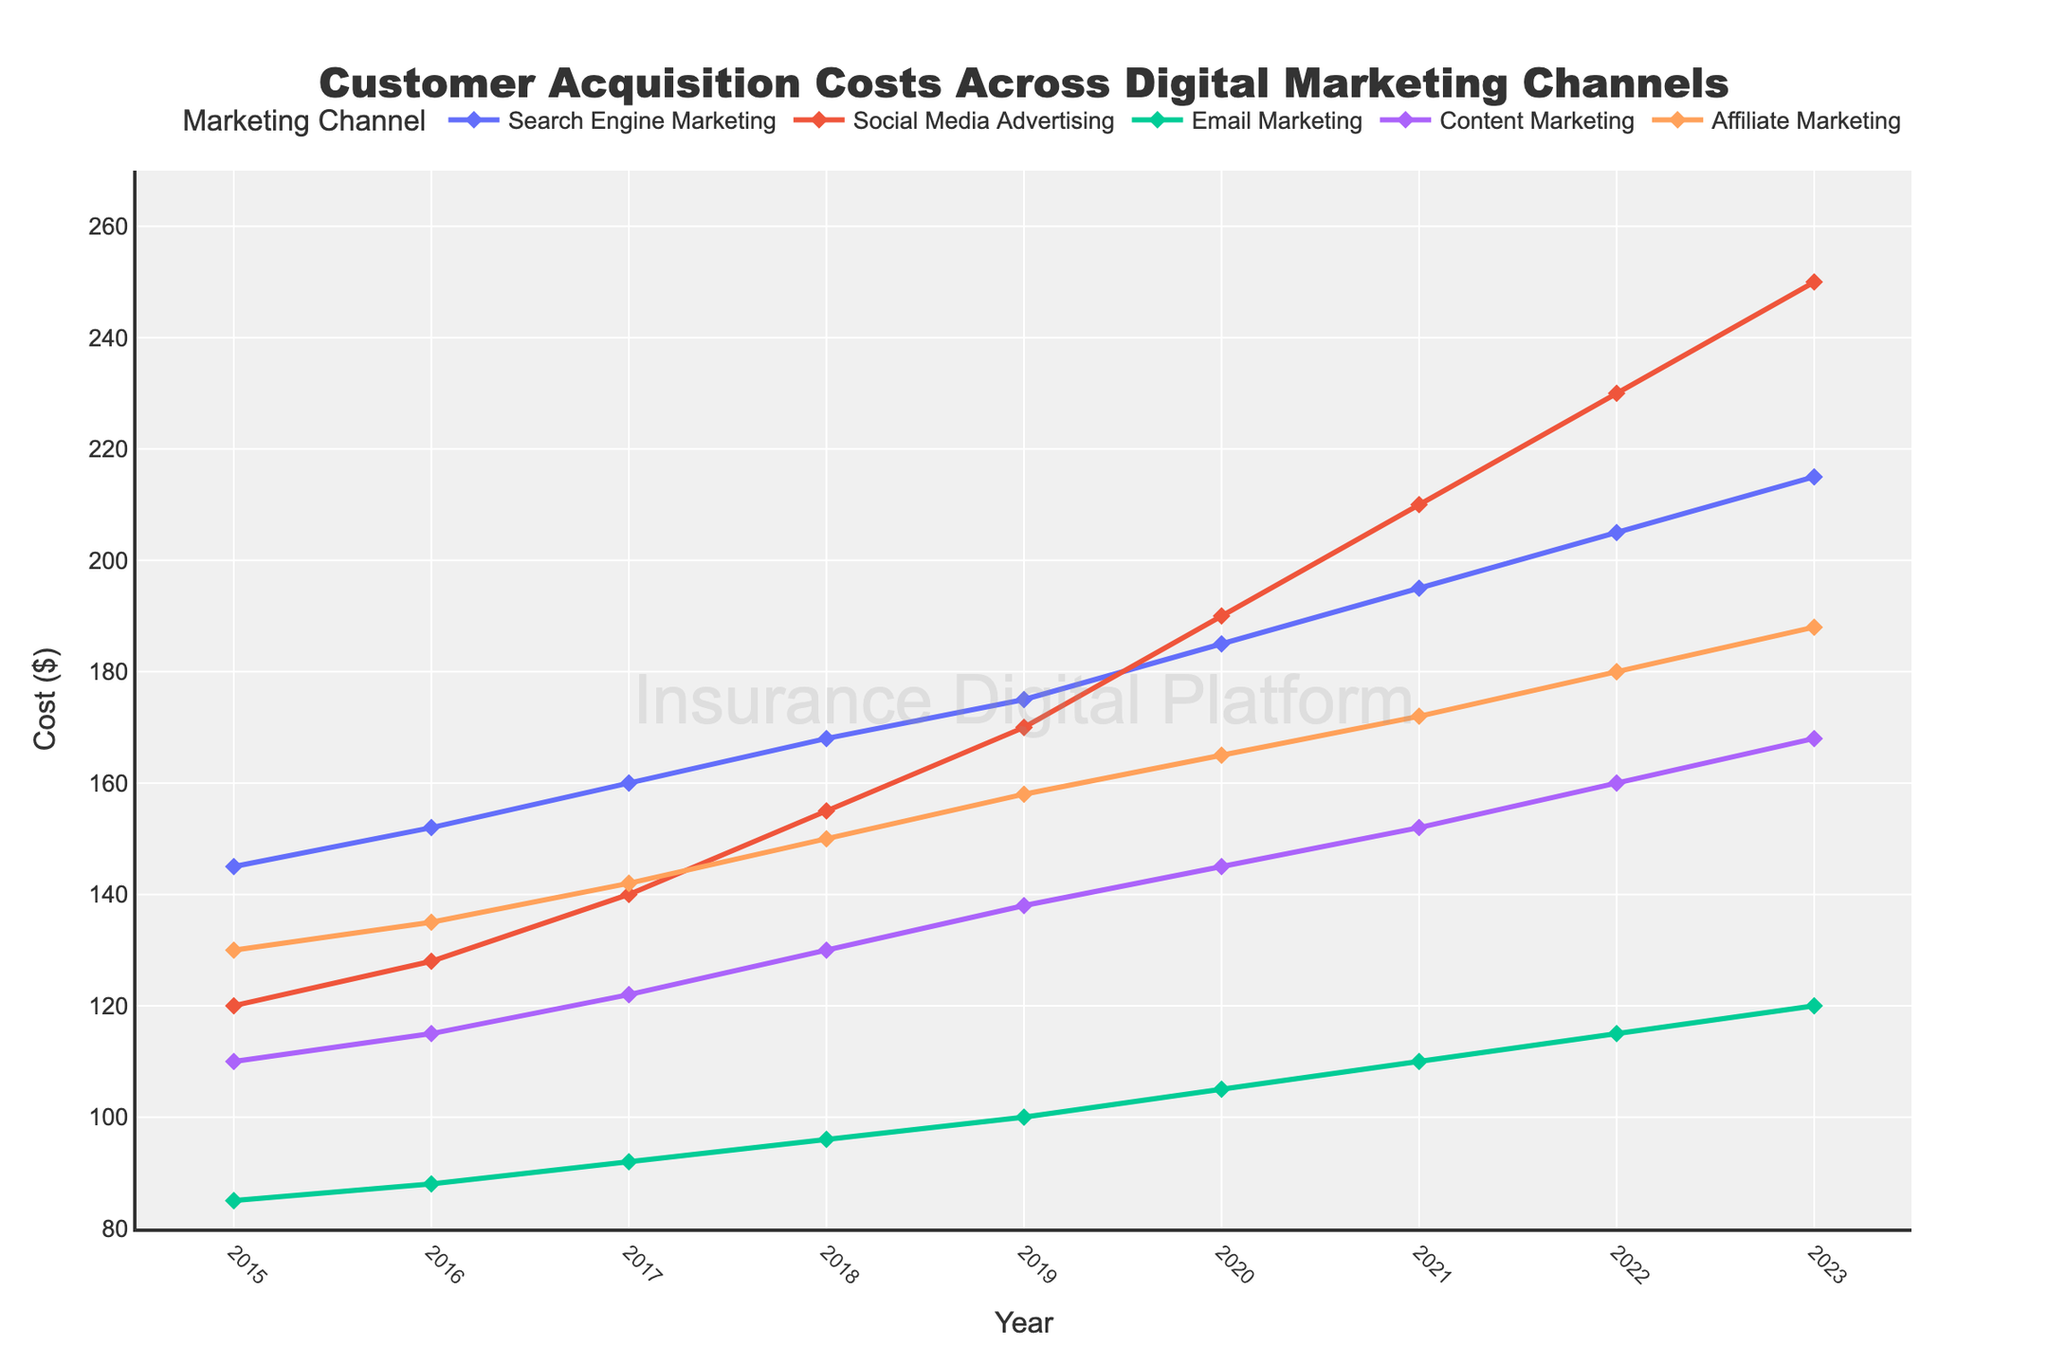what is the increase in cost for Search Engine Marketing from 2015 to 2023? First, locate the values for Search Engine Marketing in 2015 and 2023. They are $145 and $215 respectively. The increase is calculated as 215 - 145.
Answer: 70 Which digital marketing channel had the highest customer acquisition cost in 2023? Identify the cost values for all the digital marketing channels in 2023. The values are Search Engine Marketing ($215), Social Media Advertising ($250), Email Marketing ($120), Content Marketing ($168), and Affiliate Marketing ($188). Social Media Advertising has the highest value.
Answer: Social Media Advertising Between which consecutive years did Email Marketing experience the greatest increase in customer acquisition cost? Find the yearly differences for Email Marketing from 2015 to 2023: 2016-2015: 3, 2017-2016: 4, 2018-2017: 4, 2019-2018: 4, 2020-2019: 5, 2021-2020: 5, 2022-2021: 5, 2023-2022: 5. The greatest increase is from 2019 to 2020, 2020 to 2021, 2021 to 2022, and 2022 to 2023, each being 5.
Answer: 2019-2020, 2020-2021, 2021-2022, 2022-2023 Is the cost of Affiliate Marketing ever greater than Content Marketing? Compare the yearly values for Affiliate and Content Marketing. Affiliate Marketing costs are consistently higher than Content Marketing from 2015 to 2023.
Answer: Yes What is the average customer acquisition cost for Content Marketing in 2019, 2020, and 2021? The values for Content Marketing in 2019, 2020, and 2021 are $138, $145, and $152. Sum them (138 + 145 + 152 = 435) and then divide by 3.
Answer: 145 By how much did Social Media Advertising costs increase from 2021 to 2023? The values for Social Media Advertising in 2021 and 2023 are $210 and $250. The increase is calculated as 250 - 210.
Answer: 40 Which marketing channel had the lowest increase in customer acquisition costs from 2015 to 2023? Calculate the difference in costs from 2015 to 2023 for each channel: Search Engine Marketing (70), Social Media Advertising (130), Email Marketing (35), Content Marketing (58), Affiliate Marketing (58). Email Marketing has the lowest increase.
Answer: Email Marketing 